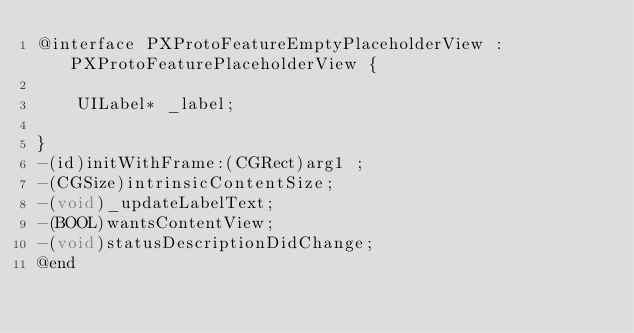<code> <loc_0><loc_0><loc_500><loc_500><_C_>@interface PXProtoFeatureEmptyPlaceholderView : PXProtoFeaturePlaceholderView {

	UILabel* _label;

}
-(id)initWithFrame:(CGRect)arg1 ;
-(CGSize)intrinsicContentSize;
-(void)_updateLabelText;
-(BOOL)wantsContentView;
-(void)statusDescriptionDidChange;
@end

</code> 